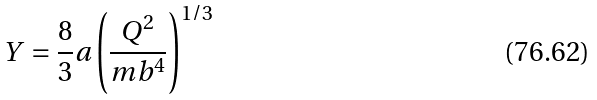Convert formula to latex. <formula><loc_0><loc_0><loc_500><loc_500>Y = \frac { 8 } { 3 } a \left ( \frac { Q ^ { 2 } } { m b ^ { 4 } } \right ) ^ { 1 / 3 }</formula> 